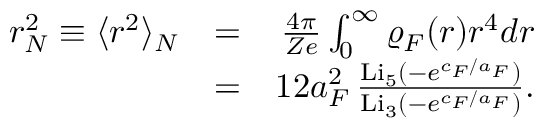Convert formula to latex. <formula><loc_0><loc_0><loc_500><loc_500>\begin{array} { r l r } { r _ { N } ^ { 2 } \equiv \langle r ^ { 2 } \rangle _ { N } } & { = } & { \frac { 4 \pi } { Z e } \int _ { 0 } ^ { \infty } \varrho _ { F } ( r ) r ^ { 4 } d r } \\ & { = } & { 1 2 a _ { F } ^ { 2 } \, \frac { L i _ { 5 } ( - e ^ { c _ { F } / a _ { F } } ) } { L i _ { 3 } ( - e ^ { c _ { F } / a _ { F } } ) } . } \end{array}</formula> 